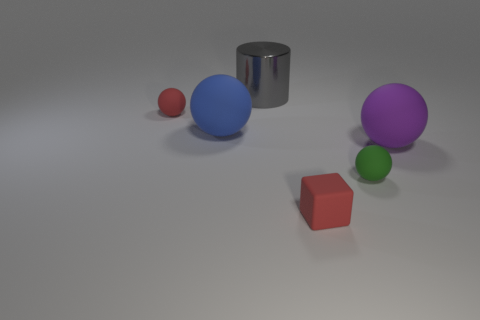Subtract all tiny green spheres. How many spheres are left? 3 Add 3 tiny rubber blocks. How many objects exist? 9 Subtract all purple balls. How many balls are left? 3 Subtract 1 spheres. How many spheres are left? 3 Subtract all spheres. How many objects are left? 2 Add 3 large metallic objects. How many large metallic objects exist? 4 Subtract 0 cyan blocks. How many objects are left? 6 Subtract all green balls. Subtract all red cylinders. How many balls are left? 3 Subtract all cyan cylinders. How many green spheres are left? 1 Subtract all small red spheres. Subtract all green spheres. How many objects are left? 4 